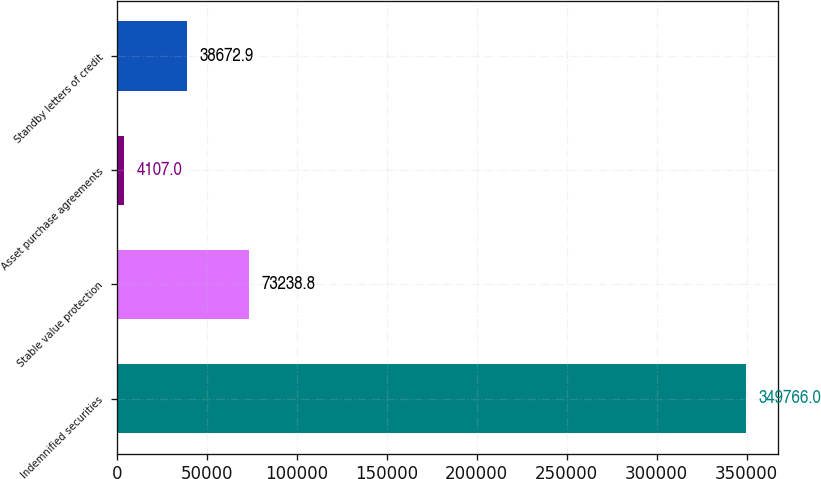Convert chart. <chart><loc_0><loc_0><loc_500><loc_500><bar_chart><fcel>Indemnified securities<fcel>Stable value protection<fcel>Asset purchase agreements<fcel>Standby letters of credit<nl><fcel>349766<fcel>73238.8<fcel>4107<fcel>38672.9<nl></chart> 